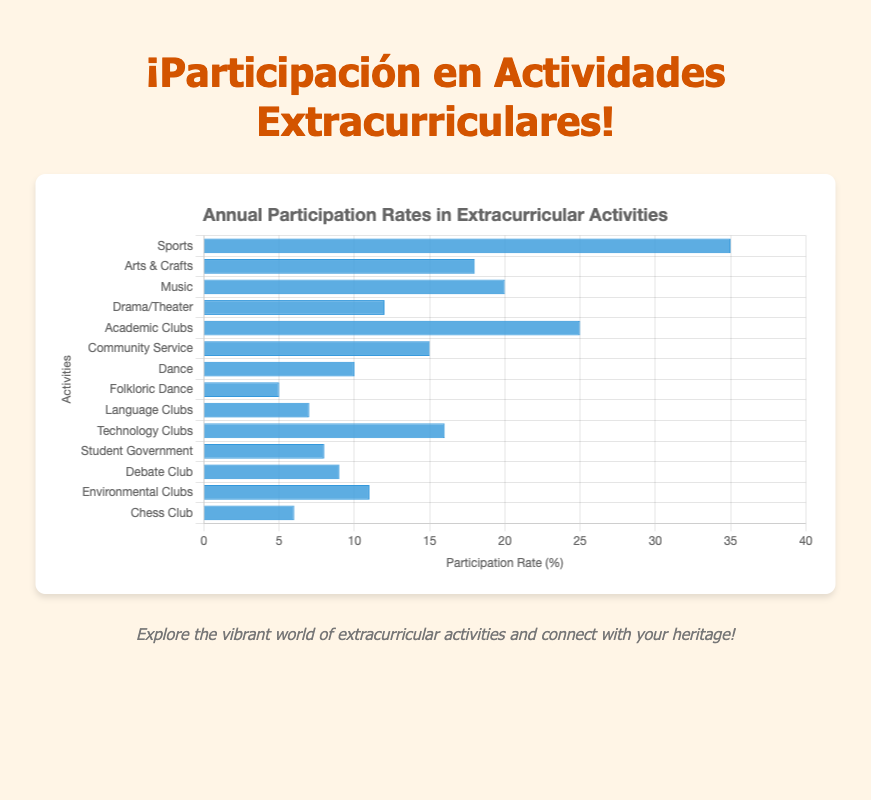Which activity has the highest participation rate? To find the activity with the highest participation rate, look for the longest blue bar in the bar chart. The activity corresponding to this bar is "Sports" with a 35% participation rate.
Answer: Sports What is the combined participation rate for Arts & Crafts and Music? First, identify the participation rates for Arts & Crafts (18%) and Music (20%). Then add these values together: 18% + 20% = 38%.
Answer: 38% Which activity has a higher participation rate: Drama/Theater or Debate Club? Find the participation rates for Drama/Theater (12%) and Debate Club (9%) by comparing the lengths of their bars. Drama/Theater has a higher participation rate.
Answer: Drama/Theater Is the participation rate for Technology Clubs greater than that for Language Clubs? Locate the bars for Technology Clubs (16%) and Language Clubs (7%). The bar for Technology Clubs is longer, indicating a higher participation rate.
Answer: Yes What is the average participation rate for Academic Clubs, Community Service, and Chess Club? Find the participation rates for Academic Clubs (25%), Community Service (15%), and Chess Club (6%). Add these values: 25% + 15% + 6% = 46%. Divide the sum by the number of activities (3), so 46% / 3 = 15.33%.
Answer: 15.33% Is the participation in Environmental Clubs higher or lower than Student Government? Compare the bars for Environmental Clubs (11%) and Student Government (8%). The bar for Environmental Clubs is longer, indicating a higher participation rate.
Answer: Higher What is the total participation rate for Dance, Folkloric Dance, and Language Clubs? Identify the participation rates for Dance (10%), Folkloric Dance (5%), and Language Clubs (7%). Then add these values together: 10% + 5% + 7% = 22%.
Answer: 22% Which is the activity with the lowest participation rate, and what is it? Look for the shortest blue bar in the bar chart. The activity with the shortest bar and thus the lowest participation rate is "Folkloric Dance" with a 5% participation rate.
Answer: Folkloric Dance By how much is the participation in Music greater than in Folkloric Dance? Identify the participation rates for Music (20%) and Folkloric Dance (5%). Subtract the smaller rate from the larger one: 20% - 5% = 15%.
Answer: 15% What is the participation rate difference between Sports and Arts & Crafts? Find the rates for Sports (35%) and Arts & Crafts (18%). Subtract the latter from the former: 35% - 18% = 17%.
Answer: 17% 